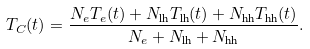<formula> <loc_0><loc_0><loc_500><loc_500>T _ { C } ( t ) = \frac { N _ { e } T _ { e } ( t ) + N _ { \text {lh} } T _ { \text {lh} } ( t ) + N _ { \text {hh} } T _ { \text {hh} } ( t ) } { N _ { e } + N _ { \text {lh} } + N _ { \text {hh} } } .</formula> 